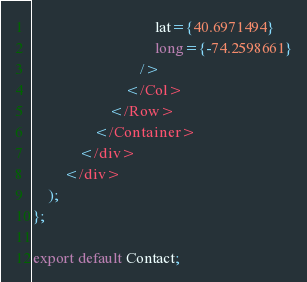Convert code to text. <code><loc_0><loc_0><loc_500><loc_500><_JavaScript_>                                lat={40.6971494}
                                long={-74.2598661}
                            />
                        </Col>
                    </Row>
                </Container>
            </div>
        </div>
    );
};

export default Contact;</code> 